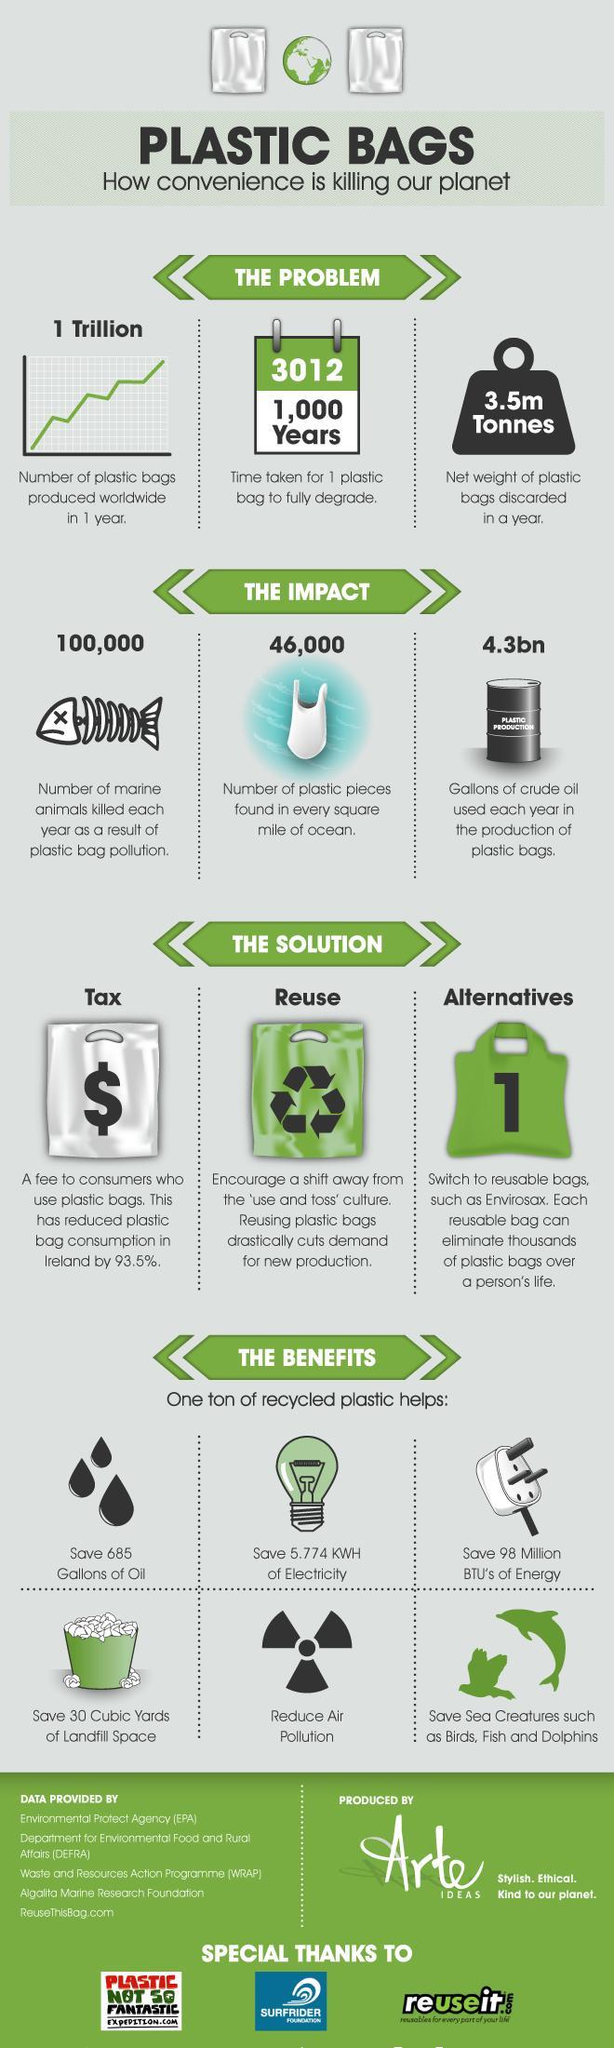How many marine lives were killed each year as a result of plastic bag pollution?
Answer the question with a short phrase. 100,000 What is the time taken for one plastic bag to fully degrade? 1,000 Years What is the number of plastic pieces found in every square mile of ocean? 46,000 What is the net weight of plastic bags discarded in a year? 3.5m Tonnes What is the number of plastic bags produced worldwide in one year? 1 Trillion What  percentage decrease is seen in the plastic bag consumption of Ireland by imposing a fine for using it? 93.5% How many gallons of crude oil is used each year in the production of plastic bags? 4.3bn 